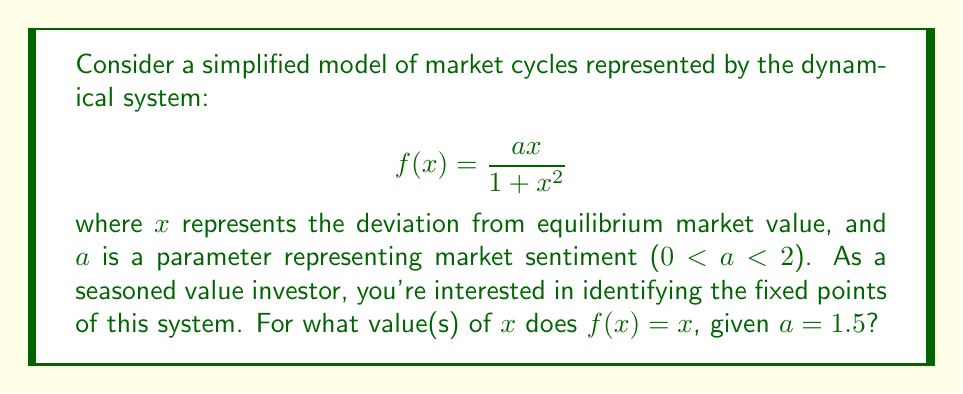Can you answer this question? To find the fixed points of the dynamical system, we need to solve the equation $f(x) = x$. Let's approach this step-by-step:

1) We start with the equation:

   $$\frac{ax}{1 + x^2} = x$$

2) Substituting $a = 1.5$:

   $$\frac{1.5x}{1 + x^2} = x$$

3) Multiply both sides by $(1 + x^2)$:

   $$1.5x = x(1 + x^2)$$

4) Expand the right side:

   $$1.5x = x + x^3$$

5) Subtract $x$ from both sides:

   $$0.5x = x^3$$

6) Subtract $x^3$ from both sides:

   $$0.5x - x^3 = 0$$

7) Factor out $x$:

   $$x(0.5 - x^2) = 0$$

8) This equation is satisfied when either $x = 0$ or $0.5 - x^2 = 0$

9) Solving $0.5 - x^2 = 0$:
   
   $x^2 = 0.5$
   $x = \pm\sqrt{0.5} = \pm\frac{\sqrt{2}}{2}$

Therefore, the fixed points of the system are $x = 0$, $x = \frac{\sqrt{2}}{2}$, and $x = -\frac{\sqrt{2}}{2}$.

In the context of market cycles, these fixed points represent:
- $x = 0$: The equilibrium market value
- $x = \pm\frac{\sqrt{2}}{2}$: Overvalued and undervalued states that persist in the model
Answer: The fixed points of the system are $x = 0$, $x = \frac{\sqrt{2}}{2}$, and $x = -\frac{\sqrt{2}}{2}$. 